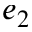Convert formula to latex. <formula><loc_0><loc_0><loc_500><loc_500>e _ { 2 }</formula> 